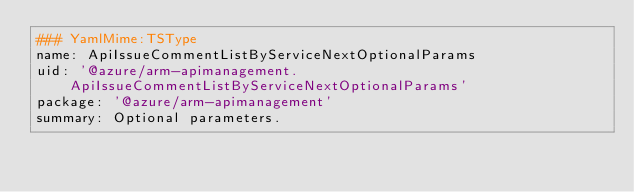Convert code to text. <code><loc_0><loc_0><loc_500><loc_500><_YAML_>### YamlMime:TSType
name: ApiIssueCommentListByServiceNextOptionalParams
uid: '@azure/arm-apimanagement.ApiIssueCommentListByServiceNextOptionalParams'
package: '@azure/arm-apimanagement'
summary: Optional parameters.</code> 